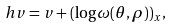<formula> <loc_0><loc_0><loc_500><loc_500>\ h v = v + ( \log \omega ( \theta , \rho ) ) _ { x } ,</formula> 